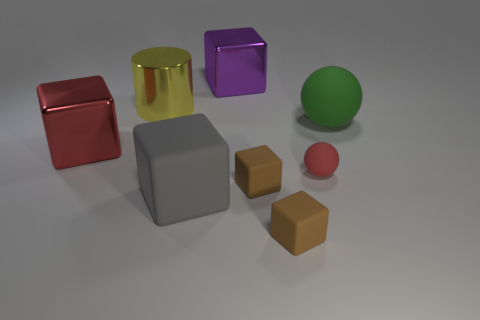Subtract all red cubes. How many cubes are left? 4 Subtract all purple cubes. How many cubes are left? 4 Subtract 2 blocks. How many blocks are left? 3 Subtract all blue cubes. Subtract all red cylinders. How many cubes are left? 5 Add 1 large gray metal balls. How many objects exist? 9 Subtract all cylinders. How many objects are left? 7 Subtract 0 blue spheres. How many objects are left? 8 Subtract all big shiny cylinders. Subtract all big gray rubber objects. How many objects are left? 6 Add 7 large blocks. How many large blocks are left? 10 Add 7 big purple blocks. How many big purple blocks exist? 8 